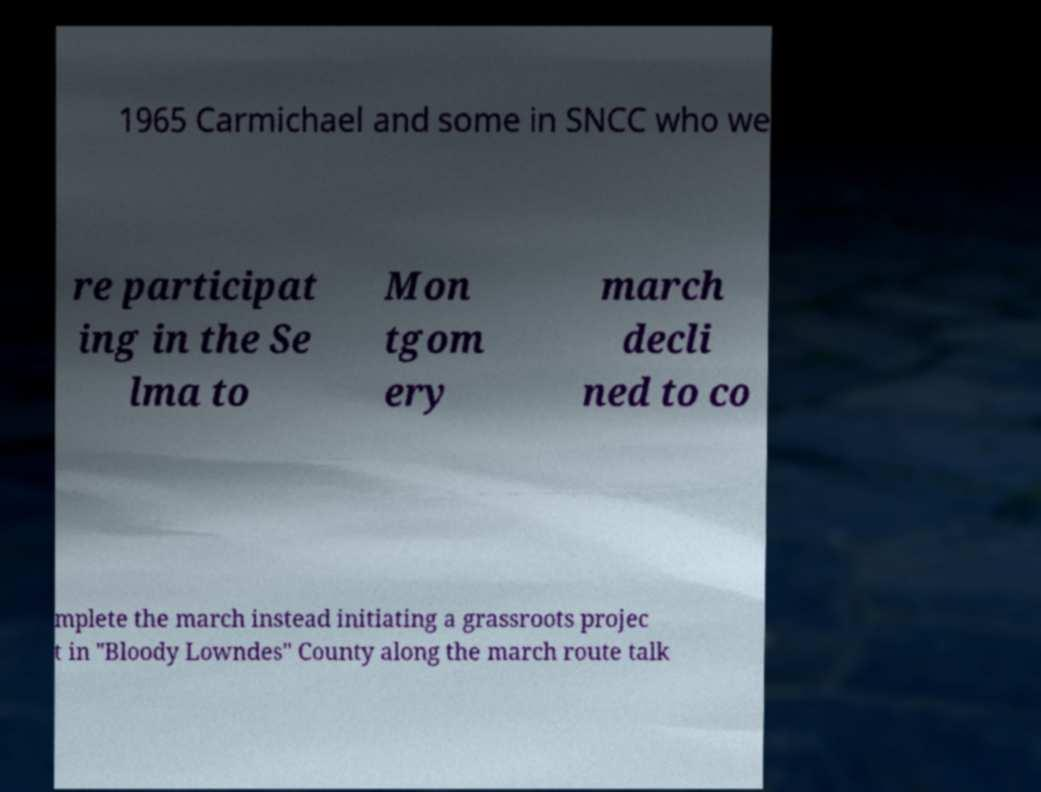Could you assist in decoding the text presented in this image and type it out clearly? 1965 Carmichael and some in SNCC who we re participat ing in the Se lma to Mon tgom ery march decli ned to co mplete the march instead initiating a grassroots projec t in "Bloody Lowndes" County along the march route talk 